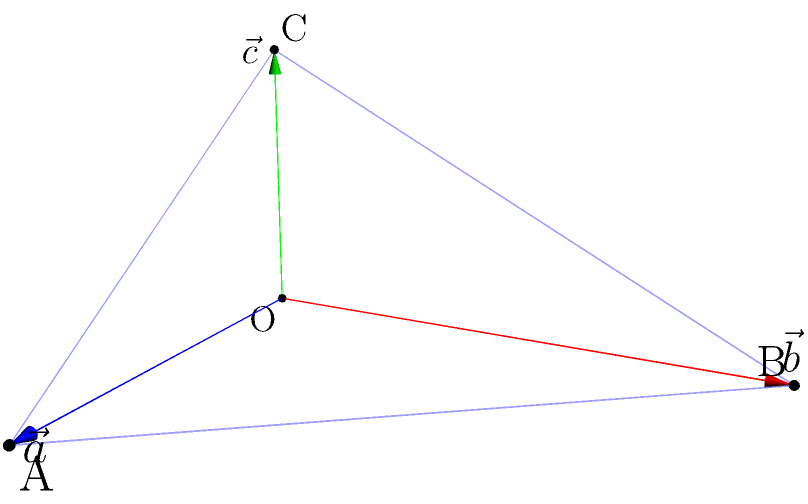As a cosplayer, you're designing an intricate triangular costume piece. The piece is defined by three vectors: $\vec{a} = 3\hat{i}$, $\vec{b} = 4\hat{j}$, and $\vec{c} = 2\hat{k}$, as shown in the figure. Calculate the surface area of this costume piece using the cross product method. To find the surface area of the triangular costume piece, we'll use the cross product method. Here's the step-by-step process:

1) The surface area of a parallelogram formed by two vectors $\vec{u}$ and $\vec{v}$ is given by the magnitude of their cross product: $A = |\vec{u} \times \vec{v}|$

2) For a triangle, we need to divide this result by 2.

3) We can use any two vectors to calculate the cross product. Let's use $\vec{a}$ and $\vec{b}$:

   $\vec{a} \times \vec{b} = \begin{vmatrix} 
   \hat{i} & \hat{j} & \hat{k} \\
   3 & 0 & 0 \\
   0 & 4 & 0
   \end{vmatrix}$

4) Calculating the determinant:
   $\vec{a} \times \vec{b} = (0\cdot0 - 0\cdot4)\hat{i} - (3\cdot0 - 0\cdot0)\hat{j} + (3\cdot4 - 0\cdot0)\hat{k}$

5) Simplifying:
   $\vec{a} \times \vec{b} = 12\hat{k}$

6) The magnitude of this vector is 12.

7) The surface area of the triangle is half of this:
   $A = \frac{1}{2}|\vec{a} \times \vec{b}| = \frac{1}{2} \cdot 12 = 6$

Therefore, the surface area of the triangular costume piece is 6 square units.
Answer: 6 square units 